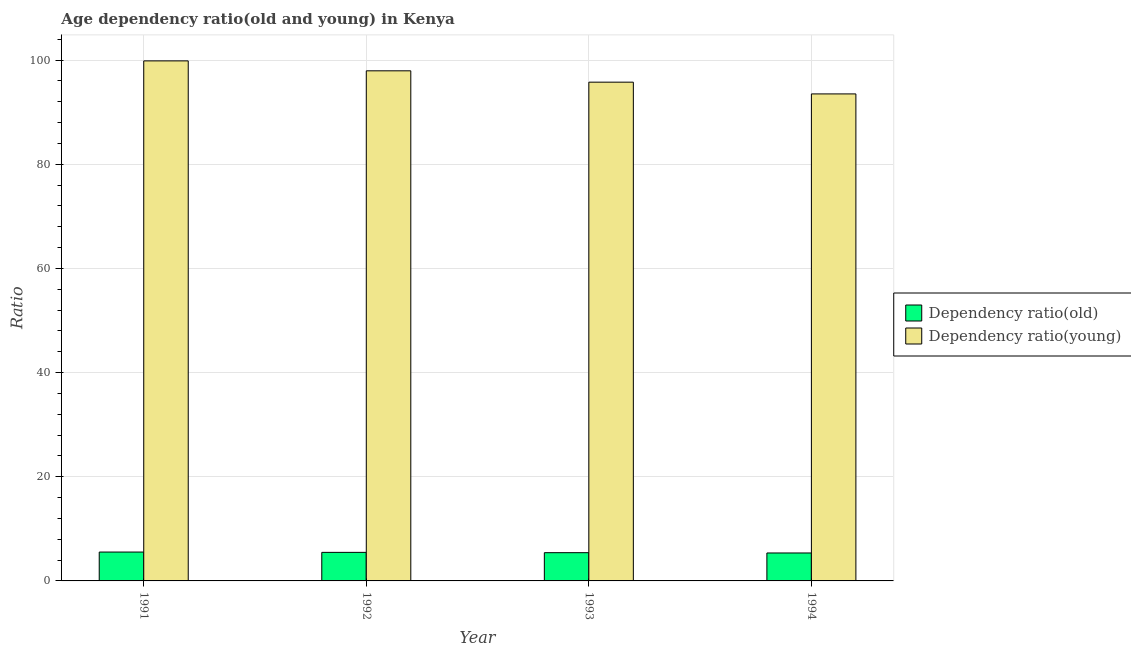How many different coloured bars are there?
Keep it short and to the point. 2. How many groups of bars are there?
Give a very brief answer. 4. Are the number of bars per tick equal to the number of legend labels?
Give a very brief answer. Yes. Are the number of bars on each tick of the X-axis equal?
Give a very brief answer. Yes. How many bars are there on the 2nd tick from the left?
Offer a very short reply. 2. What is the label of the 4th group of bars from the left?
Offer a terse response. 1994. What is the age dependency ratio(young) in 1994?
Give a very brief answer. 93.51. Across all years, what is the maximum age dependency ratio(old)?
Your answer should be compact. 5.54. Across all years, what is the minimum age dependency ratio(young)?
Your response must be concise. 93.51. In which year was the age dependency ratio(old) minimum?
Your answer should be compact. 1994. What is the total age dependency ratio(young) in the graph?
Offer a terse response. 387.09. What is the difference between the age dependency ratio(old) in 1991 and that in 1992?
Keep it short and to the point. 0.06. What is the difference between the age dependency ratio(young) in 1991 and the age dependency ratio(old) in 1993?
Ensure brevity in your answer.  4.09. What is the average age dependency ratio(old) per year?
Keep it short and to the point. 5.45. What is the ratio of the age dependency ratio(young) in 1991 to that in 1993?
Provide a short and direct response. 1.04. What is the difference between the highest and the second highest age dependency ratio(young)?
Offer a terse response. 1.91. What is the difference between the highest and the lowest age dependency ratio(young)?
Make the answer very short. 6.34. In how many years, is the age dependency ratio(young) greater than the average age dependency ratio(young) taken over all years?
Your response must be concise. 2. What does the 1st bar from the left in 1993 represents?
Keep it short and to the point. Dependency ratio(old). What does the 2nd bar from the right in 1991 represents?
Your answer should be compact. Dependency ratio(old). Where does the legend appear in the graph?
Your response must be concise. Center right. What is the title of the graph?
Your answer should be very brief. Age dependency ratio(old and young) in Kenya. What is the label or title of the Y-axis?
Provide a succinct answer. Ratio. What is the Ratio in Dependency ratio(old) in 1991?
Offer a terse response. 5.54. What is the Ratio of Dependency ratio(young) in 1991?
Give a very brief answer. 99.86. What is the Ratio in Dependency ratio(old) in 1992?
Give a very brief answer. 5.48. What is the Ratio of Dependency ratio(young) in 1992?
Provide a short and direct response. 97.95. What is the Ratio of Dependency ratio(old) in 1993?
Keep it short and to the point. 5.42. What is the Ratio in Dependency ratio(young) in 1993?
Give a very brief answer. 95.77. What is the Ratio in Dependency ratio(old) in 1994?
Give a very brief answer. 5.37. What is the Ratio in Dependency ratio(young) in 1994?
Provide a short and direct response. 93.51. Across all years, what is the maximum Ratio in Dependency ratio(old)?
Your answer should be compact. 5.54. Across all years, what is the maximum Ratio in Dependency ratio(young)?
Provide a succinct answer. 99.86. Across all years, what is the minimum Ratio in Dependency ratio(old)?
Your answer should be very brief. 5.37. Across all years, what is the minimum Ratio of Dependency ratio(young)?
Your answer should be compact. 93.51. What is the total Ratio in Dependency ratio(old) in the graph?
Offer a terse response. 21.82. What is the total Ratio of Dependency ratio(young) in the graph?
Keep it short and to the point. 387.09. What is the difference between the Ratio of Dependency ratio(old) in 1991 and that in 1992?
Your response must be concise. 0.06. What is the difference between the Ratio in Dependency ratio(young) in 1991 and that in 1992?
Keep it short and to the point. 1.91. What is the difference between the Ratio of Dependency ratio(old) in 1991 and that in 1993?
Your answer should be very brief. 0.12. What is the difference between the Ratio of Dependency ratio(young) in 1991 and that in 1993?
Your answer should be very brief. 4.09. What is the difference between the Ratio of Dependency ratio(old) in 1991 and that in 1994?
Provide a short and direct response. 0.18. What is the difference between the Ratio in Dependency ratio(young) in 1991 and that in 1994?
Provide a short and direct response. 6.34. What is the difference between the Ratio of Dependency ratio(old) in 1992 and that in 1993?
Provide a succinct answer. 0.06. What is the difference between the Ratio in Dependency ratio(young) in 1992 and that in 1993?
Provide a short and direct response. 2.18. What is the difference between the Ratio in Dependency ratio(old) in 1992 and that in 1994?
Your answer should be very brief. 0.12. What is the difference between the Ratio of Dependency ratio(young) in 1992 and that in 1994?
Offer a terse response. 4.43. What is the difference between the Ratio of Dependency ratio(old) in 1993 and that in 1994?
Offer a very short reply. 0.06. What is the difference between the Ratio in Dependency ratio(young) in 1993 and that in 1994?
Your answer should be compact. 2.26. What is the difference between the Ratio in Dependency ratio(old) in 1991 and the Ratio in Dependency ratio(young) in 1992?
Offer a very short reply. -92.41. What is the difference between the Ratio in Dependency ratio(old) in 1991 and the Ratio in Dependency ratio(young) in 1993?
Provide a succinct answer. -90.23. What is the difference between the Ratio in Dependency ratio(old) in 1991 and the Ratio in Dependency ratio(young) in 1994?
Make the answer very short. -87.97. What is the difference between the Ratio in Dependency ratio(old) in 1992 and the Ratio in Dependency ratio(young) in 1993?
Your response must be concise. -90.29. What is the difference between the Ratio in Dependency ratio(old) in 1992 and the Ratio in Dependency ratio(young) in 1994?
Give a very brief answer. -88.03. What is the difference between the Ratio of Dependency ratio(old) in 1993 and the Ratio of Dependency ratio(young) in 1994?
Provide a short and direct response. -88.09. What is the average Ratio in Dependency ratio(old) per year?
Keep it short and to the point. 5.45. What is the average Ratio in Dependency ratio(young) per year?
Give a very brief answer. 96.77. In the year 1991, what is the difference between the Ratio in Dependency ratio(old) and Ratio in Dependency ratio(young)?
Offer a very short reply. -94.31. In the year 1992, what is the difference between the Ratio in Dependency ratio(old) and Ratio in Dependency ratio(young)?
Provide a short and direct response. -92.47. In the year 1993, what is the difference between the Ratio of Dependency ratio(old) and Ratio of Dependency ratio(young)?
Give a very brief answer. -90.35. In the year 1994, what is the difference between the Ratio of Dependency ratio(old) and Ratio of Dependency ratio(young)?
Provide a short and direct response. -88.15. What is the ratio of the Ratio in Dependency ratio(old) in 1991 to that in 1992?
Your answer should be very brief. 1.01. What is the ratio of the Ratio of Dependency ratio(young) in 1991 to that in 1992?
Provide a short and direct response. 1.02. What is the ratio of the Ratio of Dependency ratio(old) in 1991 to that in 1993?
Your answer should be very brief. 1.02. What is the ratio of the Ratio of Dependency ratio(young) in 1991 to that in 1993?
Make the answer very short. 1.04. What is the ratio of the Ratio in Dependency ratio(old) in 1991 to that in 1994?
Provide a short and direct response. 1.03. What is the ratio of the Ratio of Dependency ratio(young) in 1991 to that in 1994?
Offer a terse response. 1.07. What is the ratio of the Ratio in Dependency ratio(old) in 1992 to that in 1993?
Make the answer very short. 1.01. What is the ratio of the Ratio of Dependency ratio(young) in 1992 to that in 1993?
Keep it short and to the point. 1.02. What is the ratio of the Ratio in Dependency ratio(old) in 1992 to that in 1994?
Make the answer very short. 1.02. What is the ratio of the Ratio of Dependency ratio(young) in 1992 to that in 1994?
Ensure brevity in your answer.  1.05. What is the ratio of the Ratio in Dependency ratio(old) in 1993 to that in 1994?
Your answer should be compact. 1.01. What is the ratio of the Ratio in Dependency ratio(young) in 1993 to that in 1994?
Give a very brief answer. 1.02. What is the difference between the highest and the second highest Ratio in Dependency ratio(old)?
Offer a terse response. 0.06. What is the difference between the highest and the second highest Ratio in Dependency ratio(young)?
Keep it short and to the point. 1.91. What is the difference between the highest and the lowest Ratio in Dependency ratio(old)?
Provide a succinct answer. 0.18. What is the difference between the highest and the lowest Ratio in Dependency ratio(young)?
Your response must be concise. 6.34. 